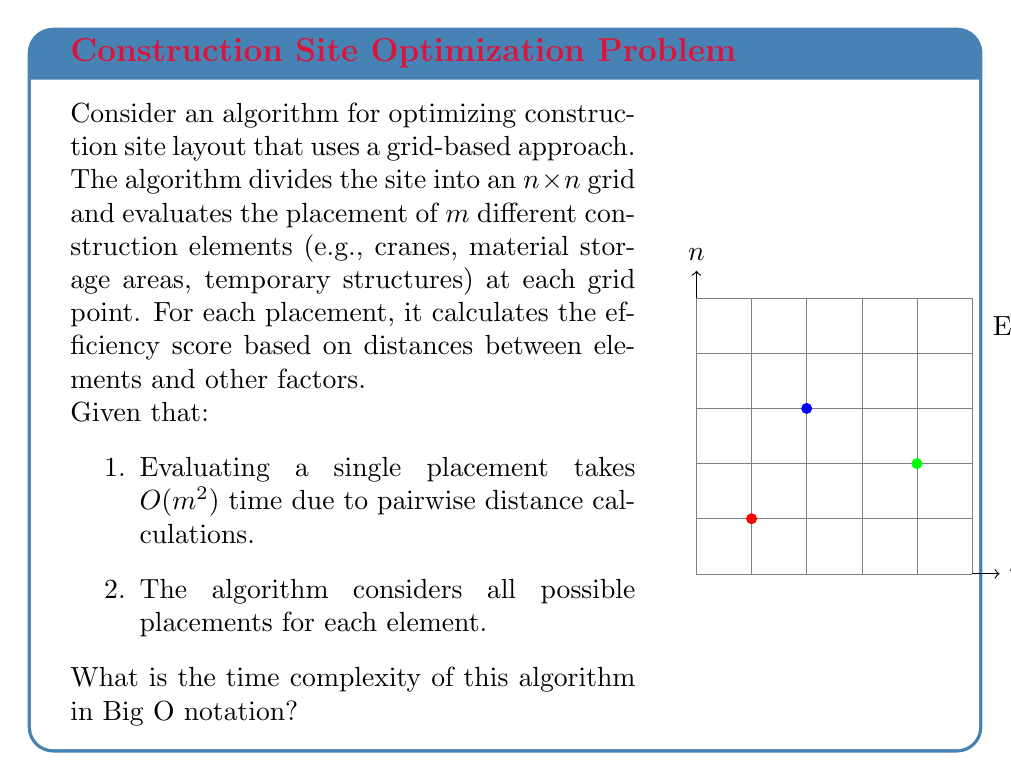Show me your answer to this math problem. Let's break down the problem step-by-step:

1) The site is divided into an $n \times n$ grid, so there are $n^2$ possible positions for each element.

2) There are $m$ elements to place, and for each element, we need to consider all $n^2$ positions.

3) For each placement of an element, we need to evaluate its efficiency, which takes $O(m^2)$ time due to pairwise distance calculations with other elements.

4) Putting this together, for each element, we perform $n^2$ evaluations, each taking $O(m^2)$ time. So for one element, the time is $O(n^2 \cdot m^2)$.

5) We do this for all $m$ elements, so we multiply by $m$:

   $O(m \cdot n^2 \cdot m^2) = O(m^3 \cdot n^2)$

6) This can be simplified to $O(m^3n^2)$.

In computational complexity theory, we typically express the time complexity in terms of the input size. Here, both $m$ and $n$ are part of the input, so we keep both in our final expression.
Answer: $O(m^3n^2)$ 